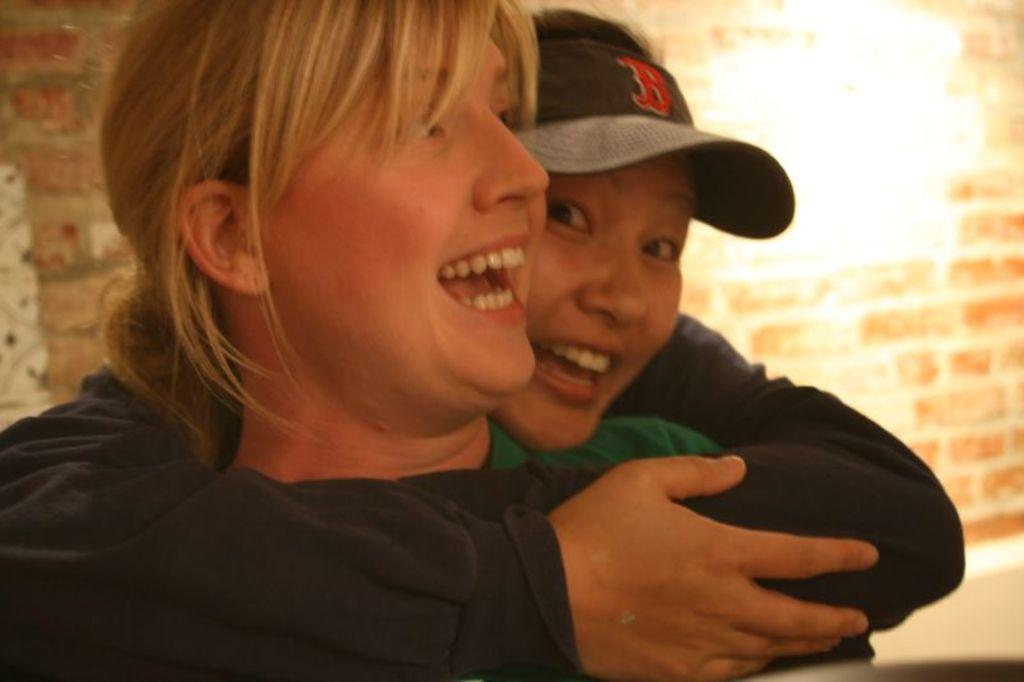How many people are in the image? There are two people in the image. What expressions do the people have on their faces? The people are wearing smiles on their faces. What can be seen in the background of the image? There is a brick wall in the background of the image. What is the temperature like in the image? The provided facts do not mention the temperature, so it cannot be determined from the image. 